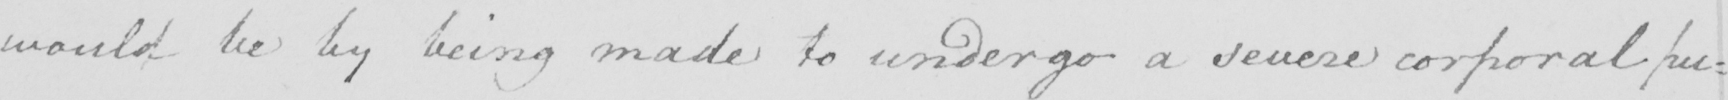What is written in this line of handwriting? would be by being made to undergo a severe corporal pu : 